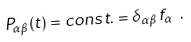<formula> <loc_0><loc_0><loc_500><loc_500>P _ { \alpha \beta } ( t ) = c o n s t . = \delta _ { \alpha \beta } \, f _ { \alpha } \ .</formula> 